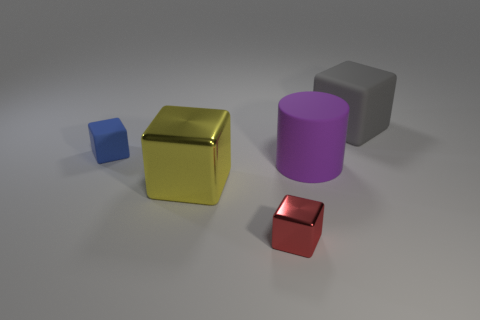Subtract 1 blocks. How many blocks are left? 3 Add 3 large gray rubber objects. How many objects exist? 8 Subtract all cylinders. How many objects are left? 4 Subtract 0 green balls. How many objects are left? 5 Subtract all tiny blue blocks. Subtract all big green rubber things. How many objects are left? 4 Add 3 purple rubber cylinders. How many purple rubber cylinders are left? 4 Add 5 blue matte objects. How many blue matte objects exist? 6 